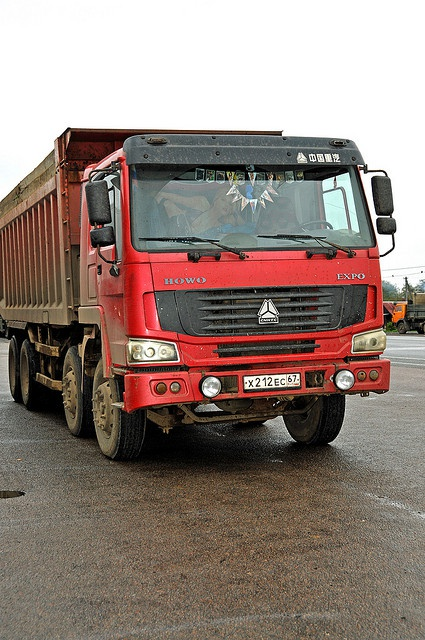Describe the objects in this image and their specific colors. I can see a truck in white, black, gray, darkgray, and maroon tones in this image. 